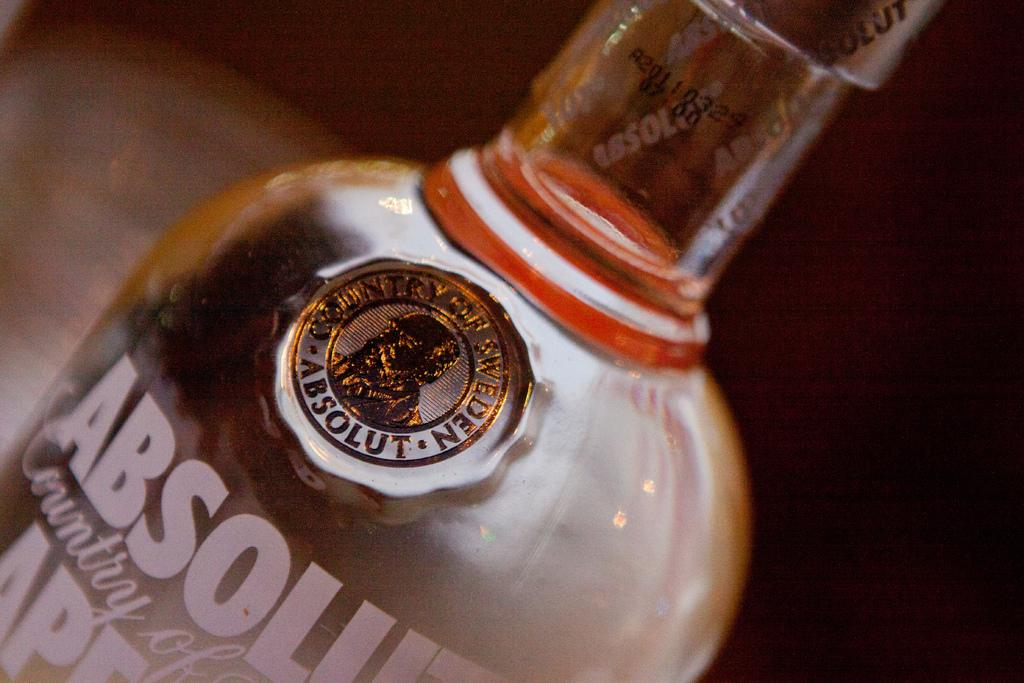<image>
Describe the image concisely. A bottle of Absolut vodka rests on a counter top. 